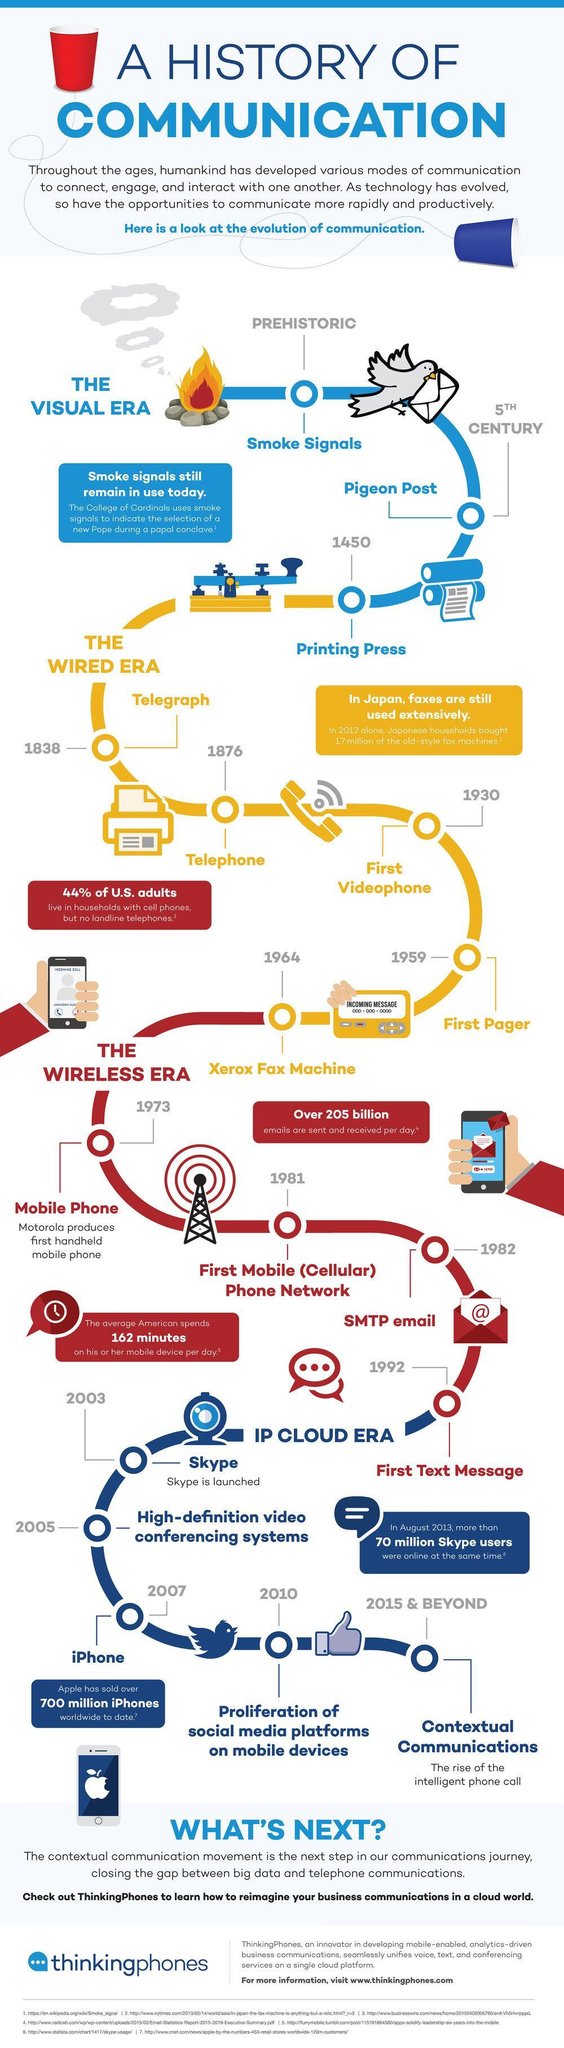The telephone was invented in which year?
Answer the question with a short phrase. 1876 The first videophone was invented in which year? 1930 The first text message was sent in which year? 1992 "Xerox Fax machine" was invented in which year? 1964 